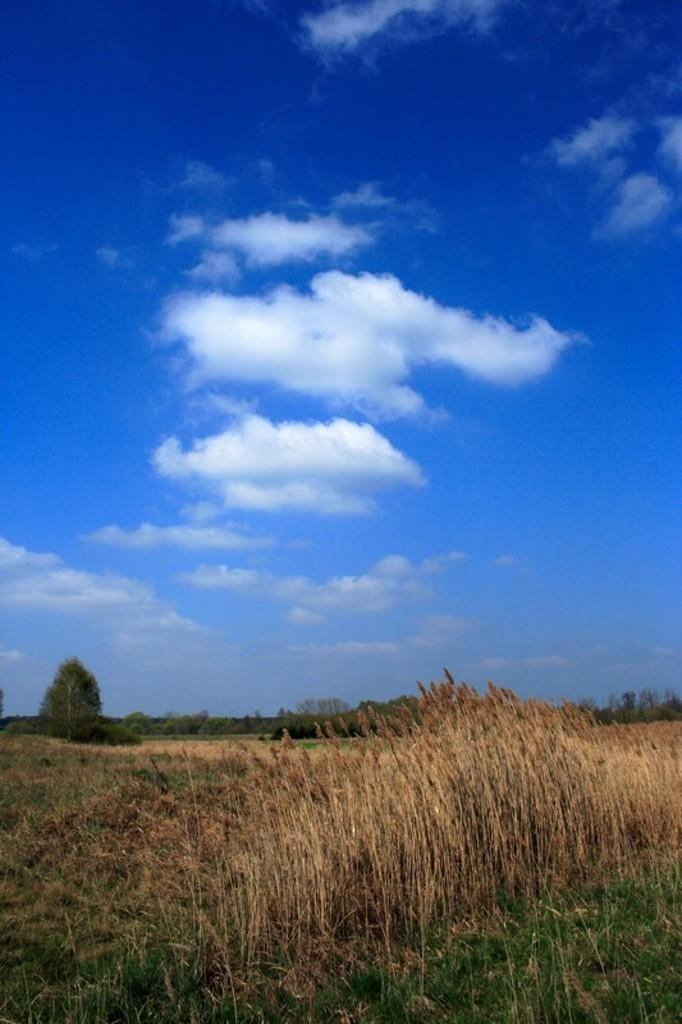What is located at the bottom of the image? There are plants and grass at the bottom of the image. What can be seen at the top of the image? The sky is visible at the top of the image. What is the condition of the sky in the image? The sky is cloudy in the image. Can you tell me how many horns are visible in the image? There are no horns present in the image. What type of treatment is being administered to the plants in the image? There is no treatment being administered to the plants in the image; they are simply growing in their natural environment. 